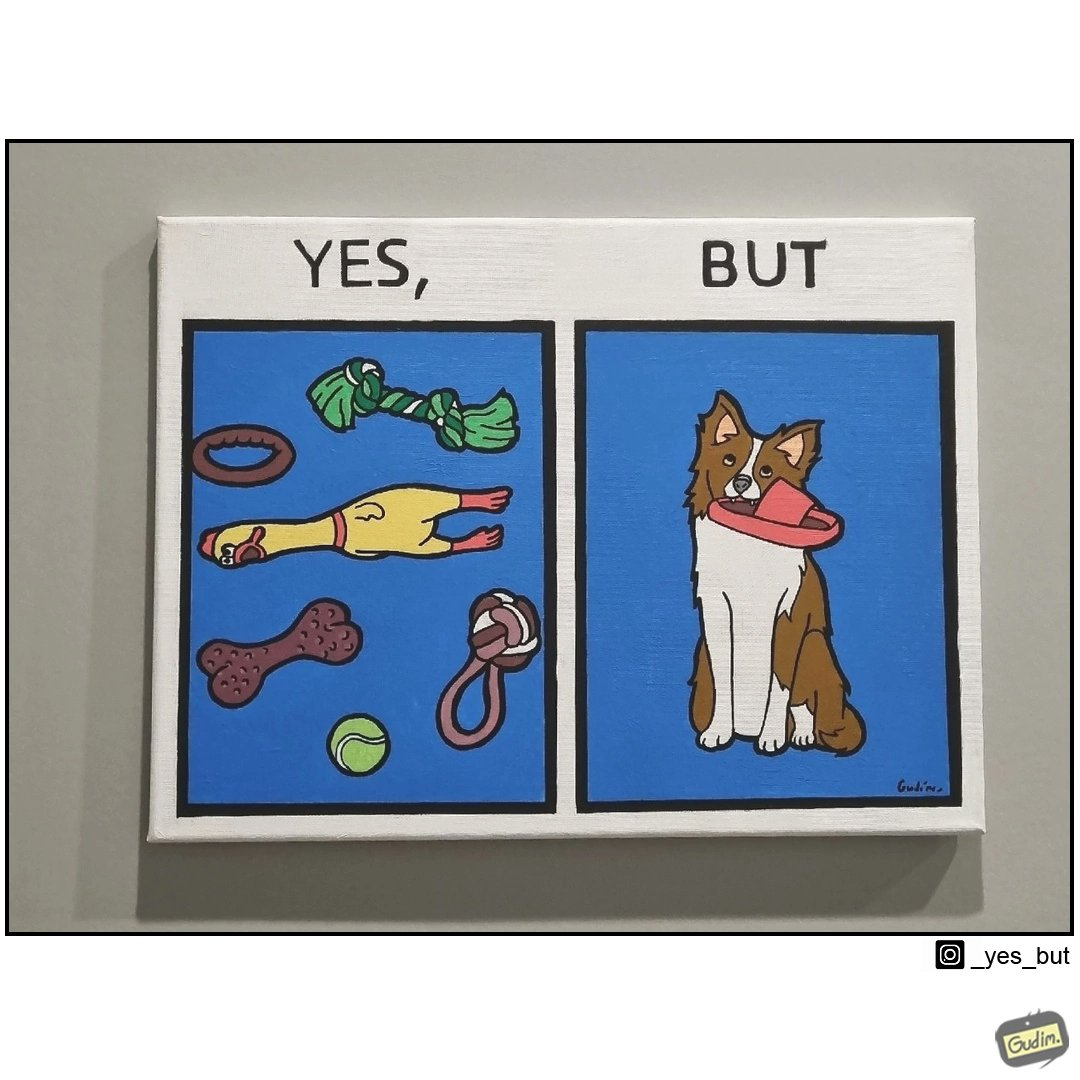Why is this image considered satirical? the irony is that dog owners buy loads of toys for their dog but the dog's favourite toy is the owner's slippers 